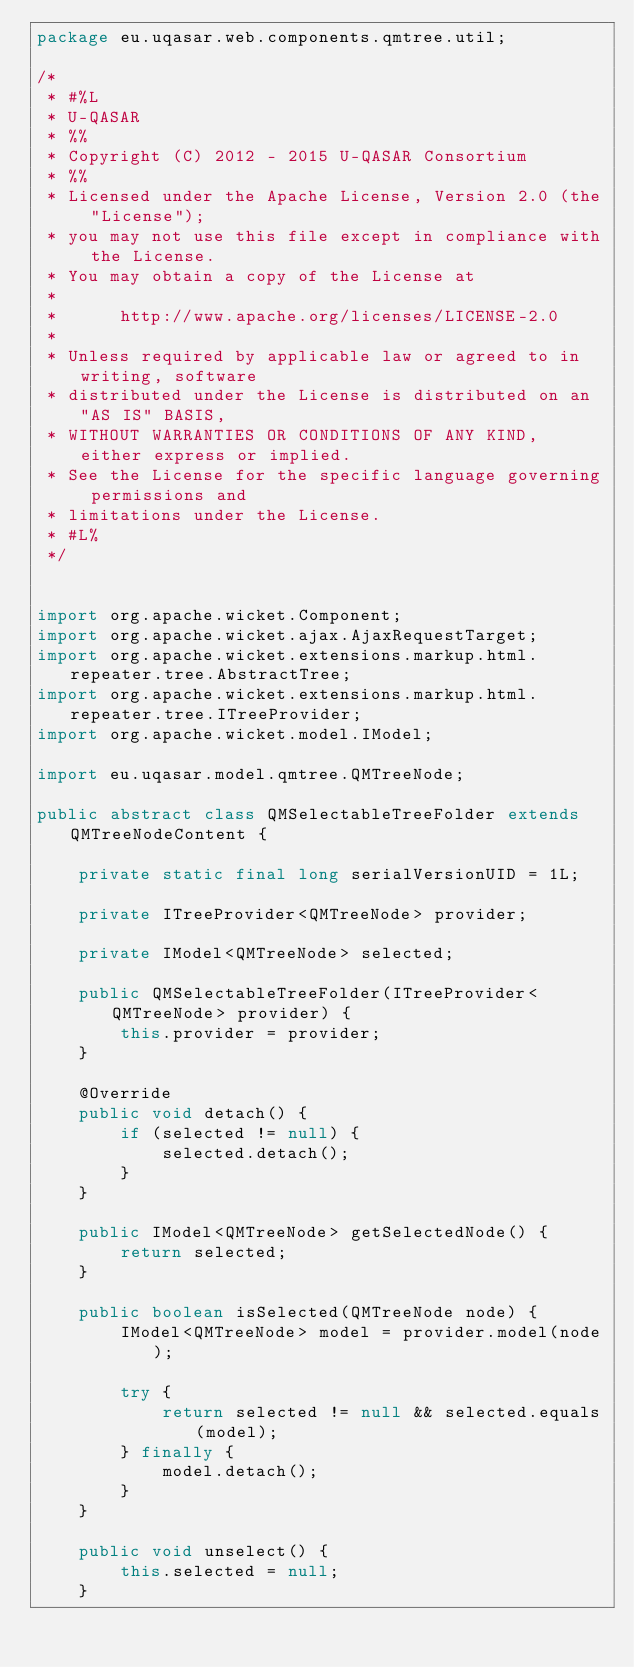Convert code to text. <code><loc_0><loc_0><loc_500><loc_500><_Java_>package eu.uqasar.web.components.qmtree.util;

/*
 * #%L
 * U-QASAR
 * %%
 * Copyright (C) 2012 - 2015 U-QASAR Consortium
 * %%
 * Licensed under the Apache License, Version 2.0 (the "License");
 * you may not use this file except in compliance with the License.
 * You may obtain a copy of the License at
 * 
 *      http://www.apache.org/licenses/LICENSE-2.0
 * 
 * Unless required by applicable law or agreed to in writing, software
 * distributed under the License is distributed on an "AS IS" BASIS,
 * WITHOUT WARRANTIES OR CONDITIONS OF ANY KIND, either express or implied.
 * See the License for the specific language governing permissions and
 * limitations under the License.
 * #L%
 */


import org.apache.wicket.Component;
import org.apache.wicket.ajax.AjaxRequestTarget;
import org.apache.wicket.extensions.markup.html.repeater.tree.AbstractTree;
import org.apache.wicket.extensions.markup.html.repeater.tree.ITreeProvider;
import org.apache.wicket.model.IModel;

import eu.uqasar.model.qmtree.QMTreeNode;

public abstract class QMSelectableTreeFolder extends QMTreeNodeContent {

	private static final long serialVersionUID = 1L;

	private ITreeProvider<QMTreeNode> provider;

	private IModel<QMTreeNode> selected;

	public QMSelectableTreeFolder(ITreeProvider<QMTreeNode> provider) {
		this.provider = provider;
	}

	@Override
	public void detach() {
		if (selected != null) {
			selected.detach();
		}
	}

	public IModel<QMTreeNode> getSelectedNode() {
		return selected;
	}

	public boolean isSelected(QMTreeNode node) {
		IModel<QMTreeNode> model = provider.model(node);

		try {
			return selected != null && selected.equals(model);
		} finally {
			model.detach();
		}
	}

	public void unselect() {
		this.selected = null;
	}
</code> 